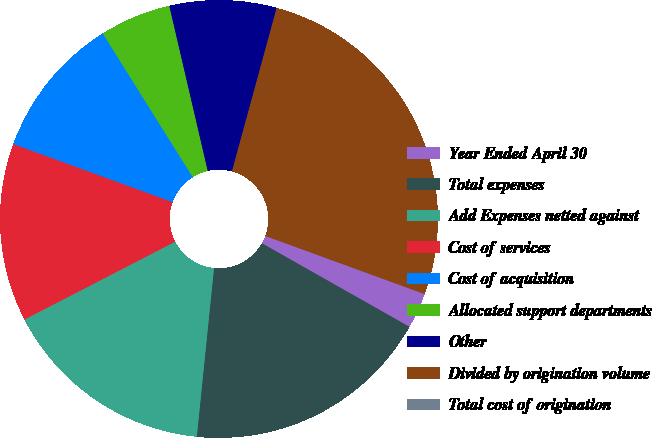Convert chart to OTSL. <chart><loc_0><loc_0><loc_500><loc_500><pie_chart><fcel>Year Ended April 30<fcel>Total expenses<fcel>Add Expenses netted against<fcel>Cost of services<fcel>Cost of acquisition<fcel>Allocated support departments<fcel>Other<fcel>Divided by origination volume<fcel>Total cost of origination<nl><fcel>2.63%<fcel>18.42%<fcel>15.79%<fcel>13.16%<fcel>10.53%<fcel>5.26%<fcel>7.89%<fcel>26.32%<fcel>0.0%<nl></chart> 